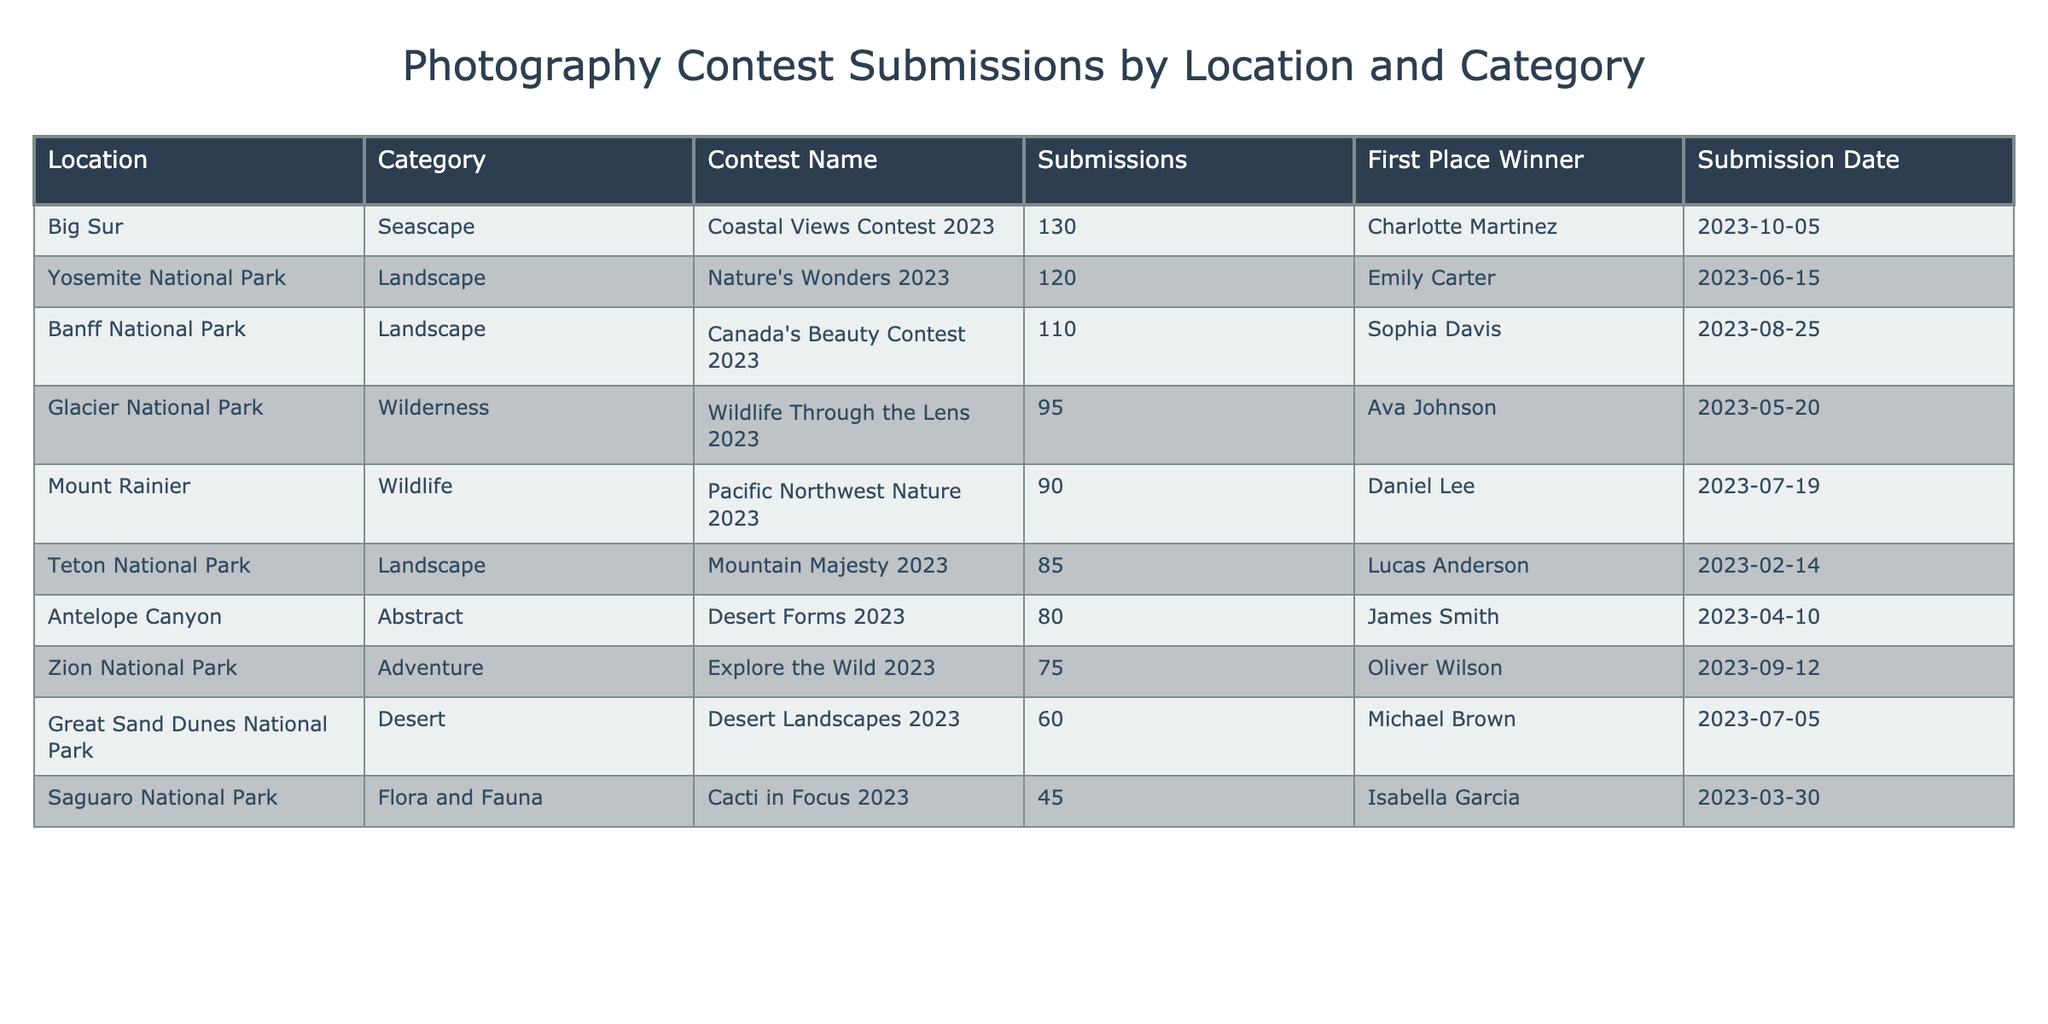What location has the highest number of submissions? By reviewing the submissions column in the table, I can identify that Big Sur has the highest submission count at 130.
Answer: Big Sur What is the total number of submissions from all locations? To find the total submissions, I sum the values in the submissions column: 120 + 80 + 95 + 60 + 110 + 75 + 45 + 90 + 130 + 85 = 1,065.
Answer: 1065 Who was the first place winner in Glacier National Park? Looking at the Glacier National Park row in the table, I see that the first place winner is Ava Johnson.
Answer: Ava Johnson Is there any location that had fewer than 50 submissions? Yes, by examining the submissions column, Saguaro National Park had 45 submissions, which is fewer than 50.
Answer: Yes What is the average number of submissions for the Desert category? The Desert category includes two locations: Great Sand Dunes National Park with 60 submissions and Antelope Canyon with 80 submissions. To find the average, I calculate the sum (60 + 80 = 140) and divide by the number of submissions (2) giving an average of 70.
Answer: 70 Which contest had the most submissions and who won? I look at the submissions for all contests and find that Nature's Wonders 2023 had the most submissions with a total of 120, and the winner was Emily Carter.
Answer: Nature's Wonders 2023, Emily Carter What percentage of submissions were from locations classified as Landscape? To calculate this, I add the submissions of Landscape category locations: Yosemite (120) + Banff (110) + Teton (85) = 315. There are 1,065 total submissions, so the percentage is (315 / 1065) * 100 ≈ 29.6%.
Answer: 29.6% Was there any Wilderness category submission that achieved first place? Checking the Wilderness category, I note that Glacier National Park is the only location here, and Ava Johnson won first place, confirming that yes, there was a winner for this category.
Answer: Yes What is the difference in submissions between the highest and lowest location? The highest submissions are from Big Sur (130) and the lowest from Saguaro National Park (45). The difference is calculated as 130 - 45 = 85.
Answer: 85 